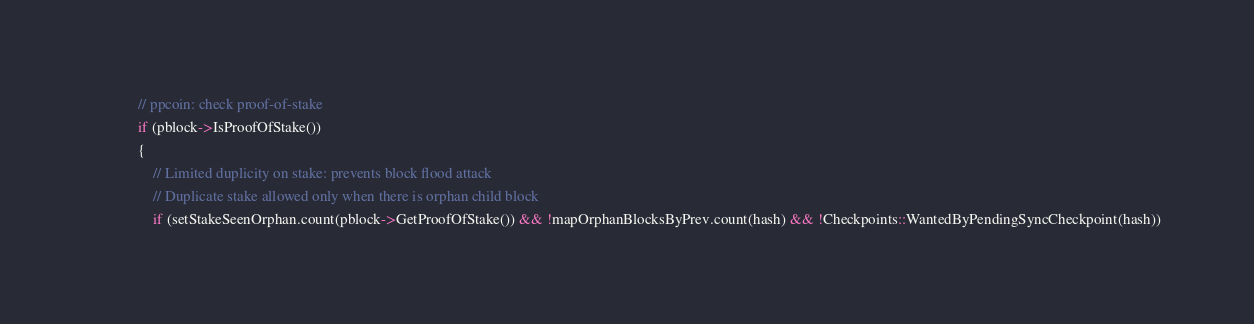Convert code to text. <code><loc_0><loc_0><loc_500><loc_500><_C++_>            // ppcoin: check proof-of-stake
            if (pblock->IsProofOfStake())
            {
                // Limited duplicity on stake: prevents block flood attack
                // Duplicate stake allowed only when there is orphan child block
                if (setStakeSeenOrphan.count(pblock->GetProofOfStake()) && !mapOrphanBlocksByPrev.count(hash) && !Checkpoints::WantedByPendingSyncCheckpoint(hash))</code> 